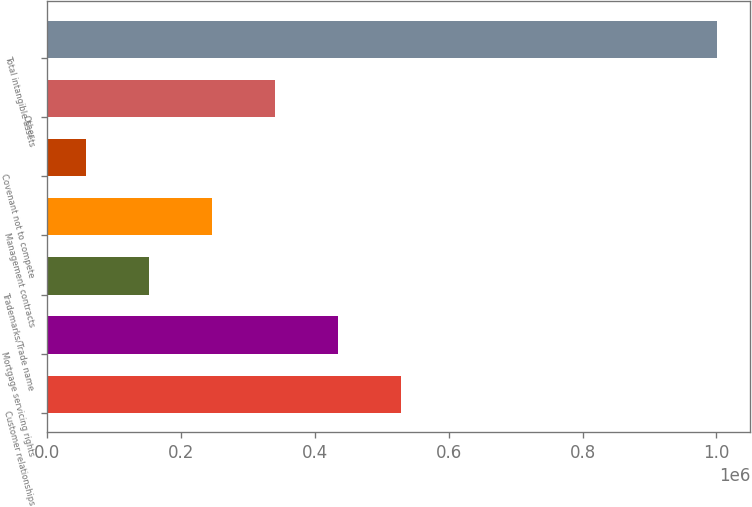Convert chart. <chart><loc_0><loc_0><loc_500><loc_500><bar_chart><fcel>Customer relationships<fcel>Mortgage servicing rights<fcel>Trademarks/Trade name<fcel>Management contracts<fcel>Covenant not to compete<fcel>Other<fcel>Total intangible assets<nl><fcel>529048<fcel>434710<fcel>151696<fcel>246034<fcel>57358<fcel>340372<fcel>1.00074e+06<nl></chart> 